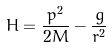<formula> <loc_0><loc_0><loc_500><loc_500>H = \frac { p ^ { 2 } } { 2 M } - \frac { g } { r ^ { 2 } } \,</formula> 